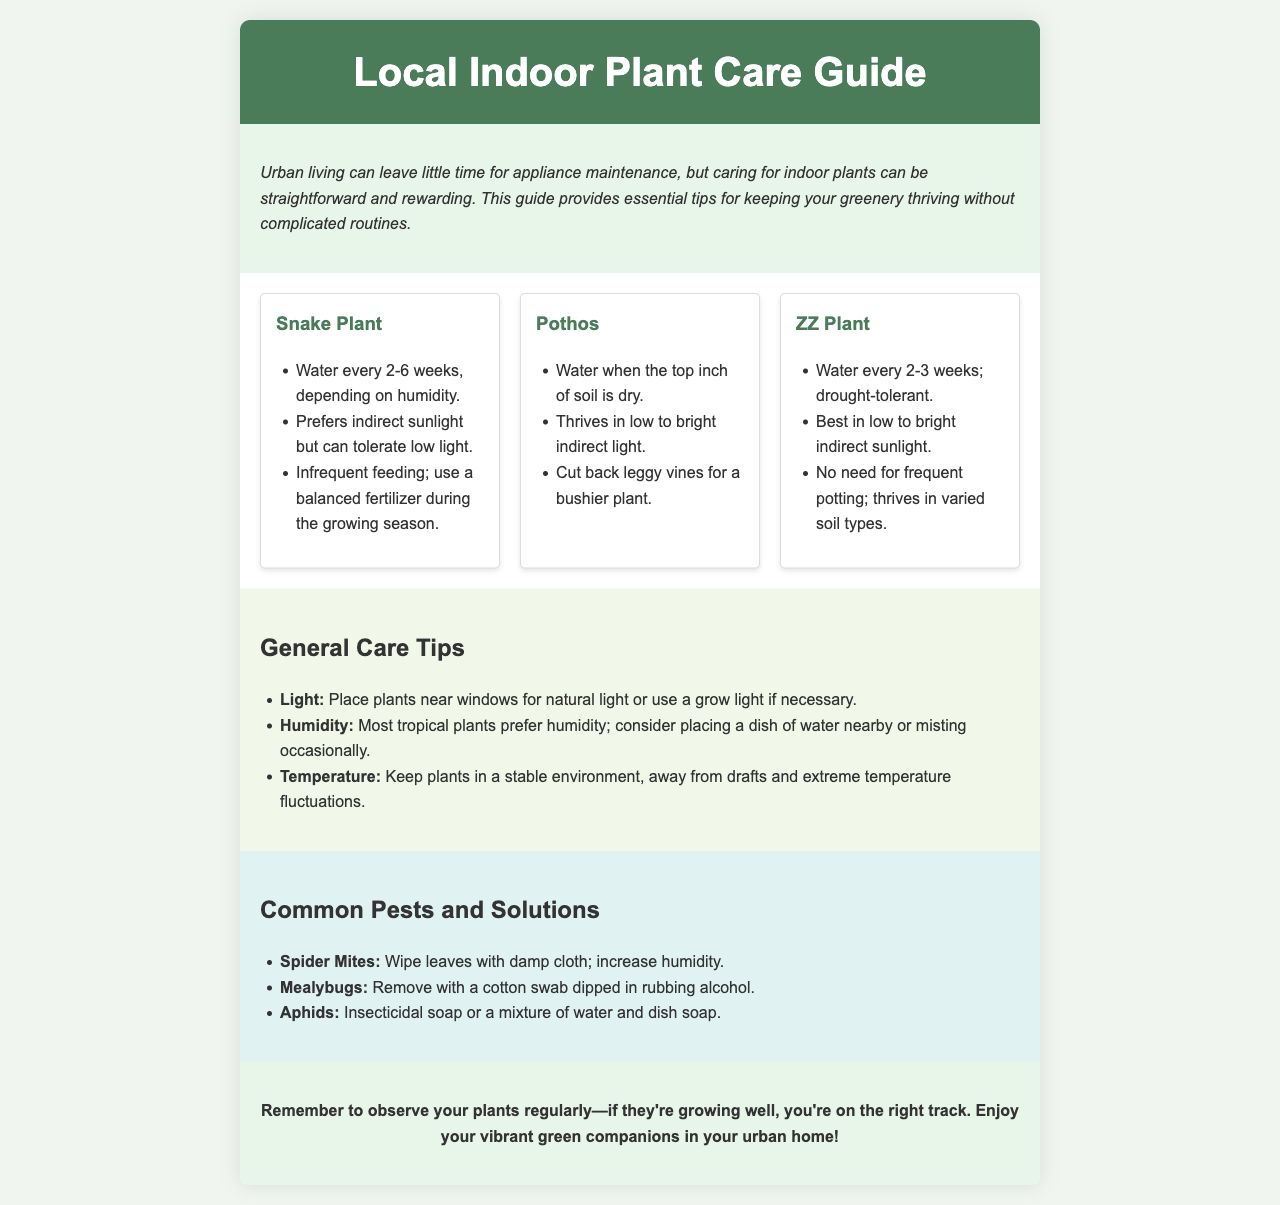What is the title of the document? The title is indicated in the header of the document.
Answer: Local Indoor Plant Care Guide How often should you water a Snake Plant? The watering frequency for a Snake Plant is specifically mentioned in the document.
Answer: Every 2-6 weeks What type of light does a Pothos thrive in? The document outlines the light conditions suitable for a Pothos.
Answer: Low to bright indirect light What should you use to remove Mealybugs? The document provides a specific method for pest control concerning Mealybugs.
Answer: Cotton swab dipped in rubbing alcohol Which plant is drought-tolerant? The characteristic of drought tolerance is explicitly mentioned for one of the plants.
Answer: ZZ Plant What is a suggested humidity solution for tropical plants? The document suggests a method for increasing humidity for plants.
Answer: Place a dish of water nearby How should you handle leggy vines on a Pothos? The document gives advice on maintaining Pothos plants regarding leggy vines.
Answer: Cut back What is emphasized as important in the final tips? The final tips section highlights the significance of a specific activity regarding plant care.
Answer: Observe your plants regularly 